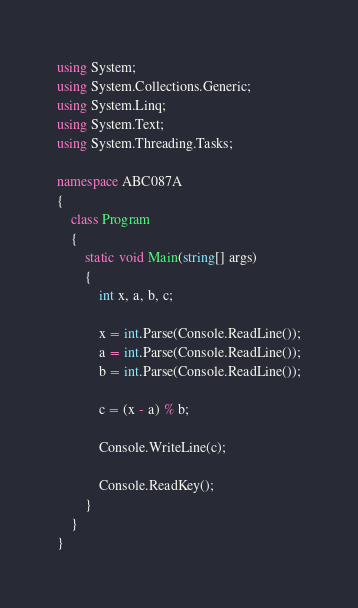Convert code to text. <code><loc_0><loc_0><loc_500><loc_500><_C#_>using System;
using System.Collections.Generic;
using System.Linq;
using System.Text;
using System.Threading.Tasks;

namespace ABC087A
{
    class Program
    {
        static void Main(string[] args)
        {
            int x, a, b, c;

            x = int.Parse(Console.ReadLine());
            a = int.Parse(Console.ReadLine());
            b = int.Parse(Console.ReadLine());

            c = (x - a) % b;

            Console.WriteLine(c);

            Console.ReadKey();
        }
    }
}
</code> 